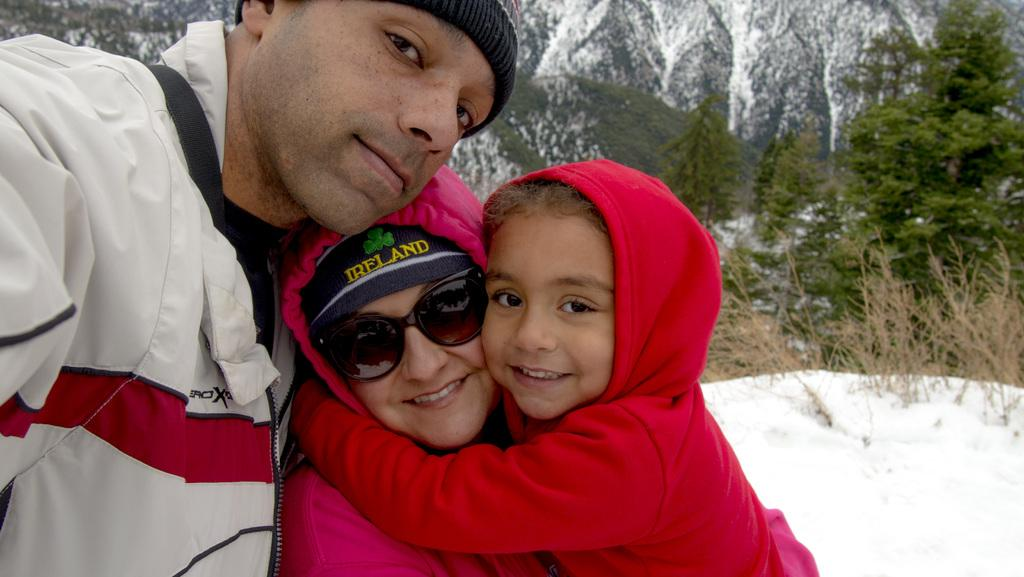How many people are present in the image? There are three people in the image. What can be seen in the background of the image? There is snow and trees visible in the background of the image. What type of science experiment is being conducted by the people in the image? There is no indication of a science experiment being conducted in the image; it simply shows three people in a snowy environment with trees in the background. 